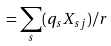Convert formula to latex. <formula><loc_0><loc_0><loc_500><loc_500>= \sum _ { s } ( q _ { s } X _ { s j } ) / r</formula> 